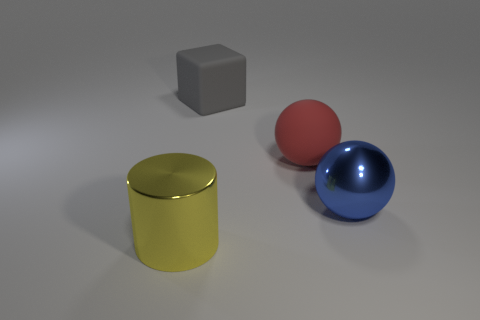Add 4 large yellow things. How many objects exist? 8 Subtract all cylinders. How many objects are left? 3 Subtract all small cyan objects. Subtract all big red spheres. How many objects are left? 3 Add 3 large gray objects. How many large gray objects are left? 4 Add 2 red rubber cubes. How many red rubber cubes exist? 2 Subtract 0 purple cylinders. How many objects are left? 4 